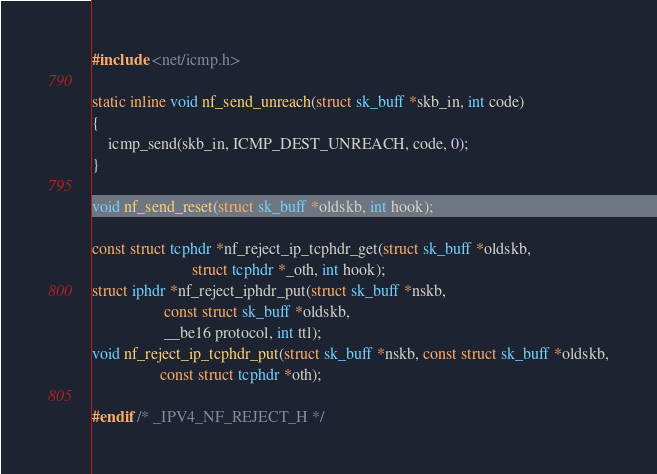Convert code to text. <code><loc_0><loc_0><loc_500><loc_500><_C_>#include <net/icmp.h>

static inline void nf_send_unreach(struct sk_buff *skb_in, int code)
{
	icmp_send(skb_in, ICMP_DEST_UNREACH, code, 0);
}

void nf_send_reset(struct sk_buff *oldskb, int hook);

const struct tcphdr *nf_reject_ip_tcphdr_get(struct sk_buff *oldskb,
					     struct tcphdr *_oth, int hook);
struct iphdr *nf_reject_iphdr_put(struct sk_buff *nskb,
				  const struct sk_buff *oldskb,
				  __be16 protocol, int ttl);
void nf_reject_ip_tcphdr_put(struct sk_buff *nskb, const struct sk_buff *oldskb,
			     const struct tcphdr *oth);

#endif /* _IPV4_NF_REJECT_H */
</code> 